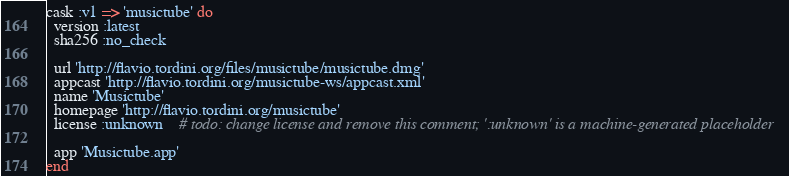<code> <loc_0><loc_0><loc_500><loc_500><_Ruby_>cask :v1 => 'musictube' do
  version :latest
  sha256 :no_check

  url 'http://flavio.tordini.org/files/musictube/musictube.dmg'
  appcast 'http://flavio.tordini.org/musictube-ws/appcast.xml'
  name 'Musictube'
  homepage 'http://flavio.tordini.org/musictube'
  license :unknown    # todo: change license and remove this comment; ':unknown' is a machine-generated placeholder

  app 'Musictube.app'
end
</code> 